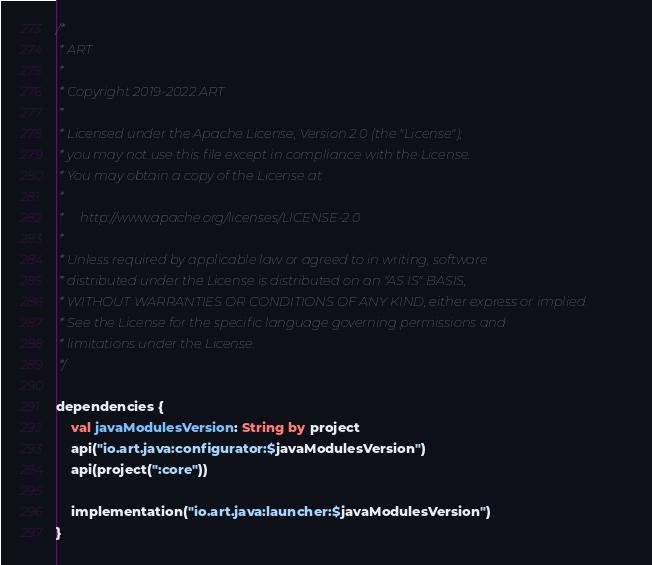<code> <loc_0><loc_0><loc_500><loc_500><_Kotlin_>/*
 * ART
 *
 * Copyright 2019-2022 ART
 *
 * Licensed under the Apache License, Version 2.0 (the "License");
 * you may not use this file except in compliance with the License.
 * You may obtain a copy of the License at
 *
 *     http://www.apache.org/licenses/LICENSE-2.0
 *
 * Unless required by applicable law or agreed to in writing, software
 * distributed under the License is distributed on an "AS IS" BASIS,
 * WITHOUT WARRANTIES OR CONDITIONS OF ANY KIND, either express or implied.
 * See the License for the specific language governing permissions and
 * limitations under the License.
 */

dependencies {
    val javaModulesVersion: String by project
    api("io.art.java:configurator:$javaModulesVersion")
    api(project(":core"))

    implementation("io.art.java:launcher:$javaModulesVersion")
}
</code> 